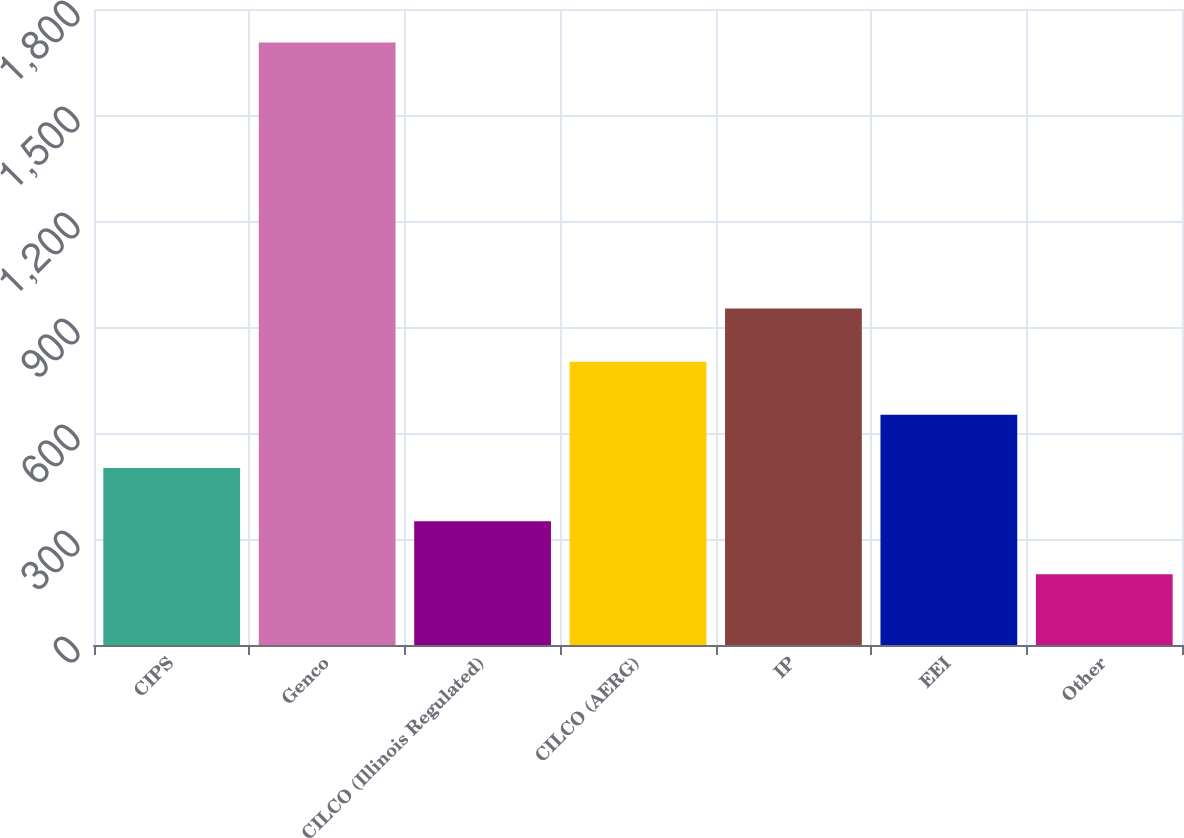Convert chart to OTSL. <chart><loc_0><loc_0><loc_500><loc_500><bar_chart><fcel>CIPS<fcel>Genco<fcel>CILCO (Illinois Regulated)<fcel>CILCO (AERG)<fcel>IP<fcel>EEI<fcel>Other<nl><fcel>501<fcel>1705<fcel>350.5<fcel>802<fcel>952.5<fcel>651.5<fcel>200<nl></chart> 